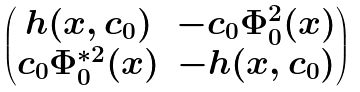Convert formula to latex. <formula><loc_0><loc_0><loc_500><loc_500>\begin{pmatrix} { h } ( x , c _ { 0 } ) & - c _ { 0 } \Phi _ { 0 } ^ { 2 } ( x ) \\ c _ { 0 } \Phi _ { 0 } ^ { * 2 } ( x ) & - { h } ( x , c _ { 0 } ) \end{pmatrix}</formula> 